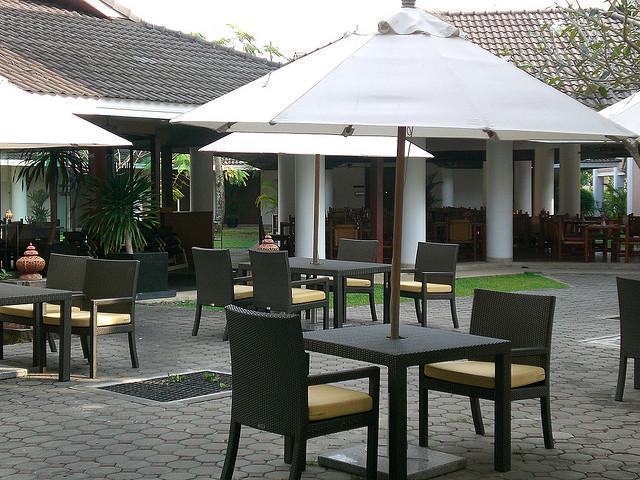What is the purpose of the umbrellas?
Choose the correct response, then elucidate: 'Answer: answer
Rationale: rationale.'
Options: Decorative, hide people, sun protection, rain protection. Answer: sun protection.
Rationale: The umbrellas are used for sun protection. 